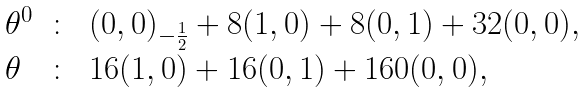<formula> <loc_0><loc_0><loc_500><loc_500>\begin{array} { l c l } \theta ^ { 0 } & \colon & ( 0 , 0 ) _ { - \frac { 1 } { 2 } } + 8 ( 1 , 0 ) + 8 ( 0 , 1 ) + 3 2 ( 0 , 0 ) , \\ \theta & \colon & 1 6 ( 1 , 0 ) + 1 6 ( 0 , 1 ) + 1 6 0 ( 0 , 0 ) , \end{array}</formula> 